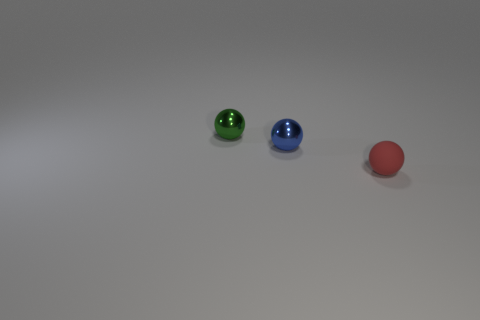What might these three objects symbolize if this were an art piece? If we interpret the three objects as elements of an art piece, they might represent concepts such as diversity and unity. The varying colors could symbolize different identities or ideas, while the identical spherical shapes suggest a fundamental commonality underlying the differences. 